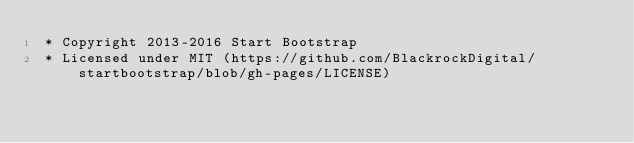Convert code to text. <code><loc_0><loc_0><loc_500><loc_500><_CSS_> * Copyright 2013-2016 Start Bootstrap
 * Licensed under MIT (https://github.com/BlackrockDigital/startbootstrap/blob/gh-pages/LICENSE)</code> 